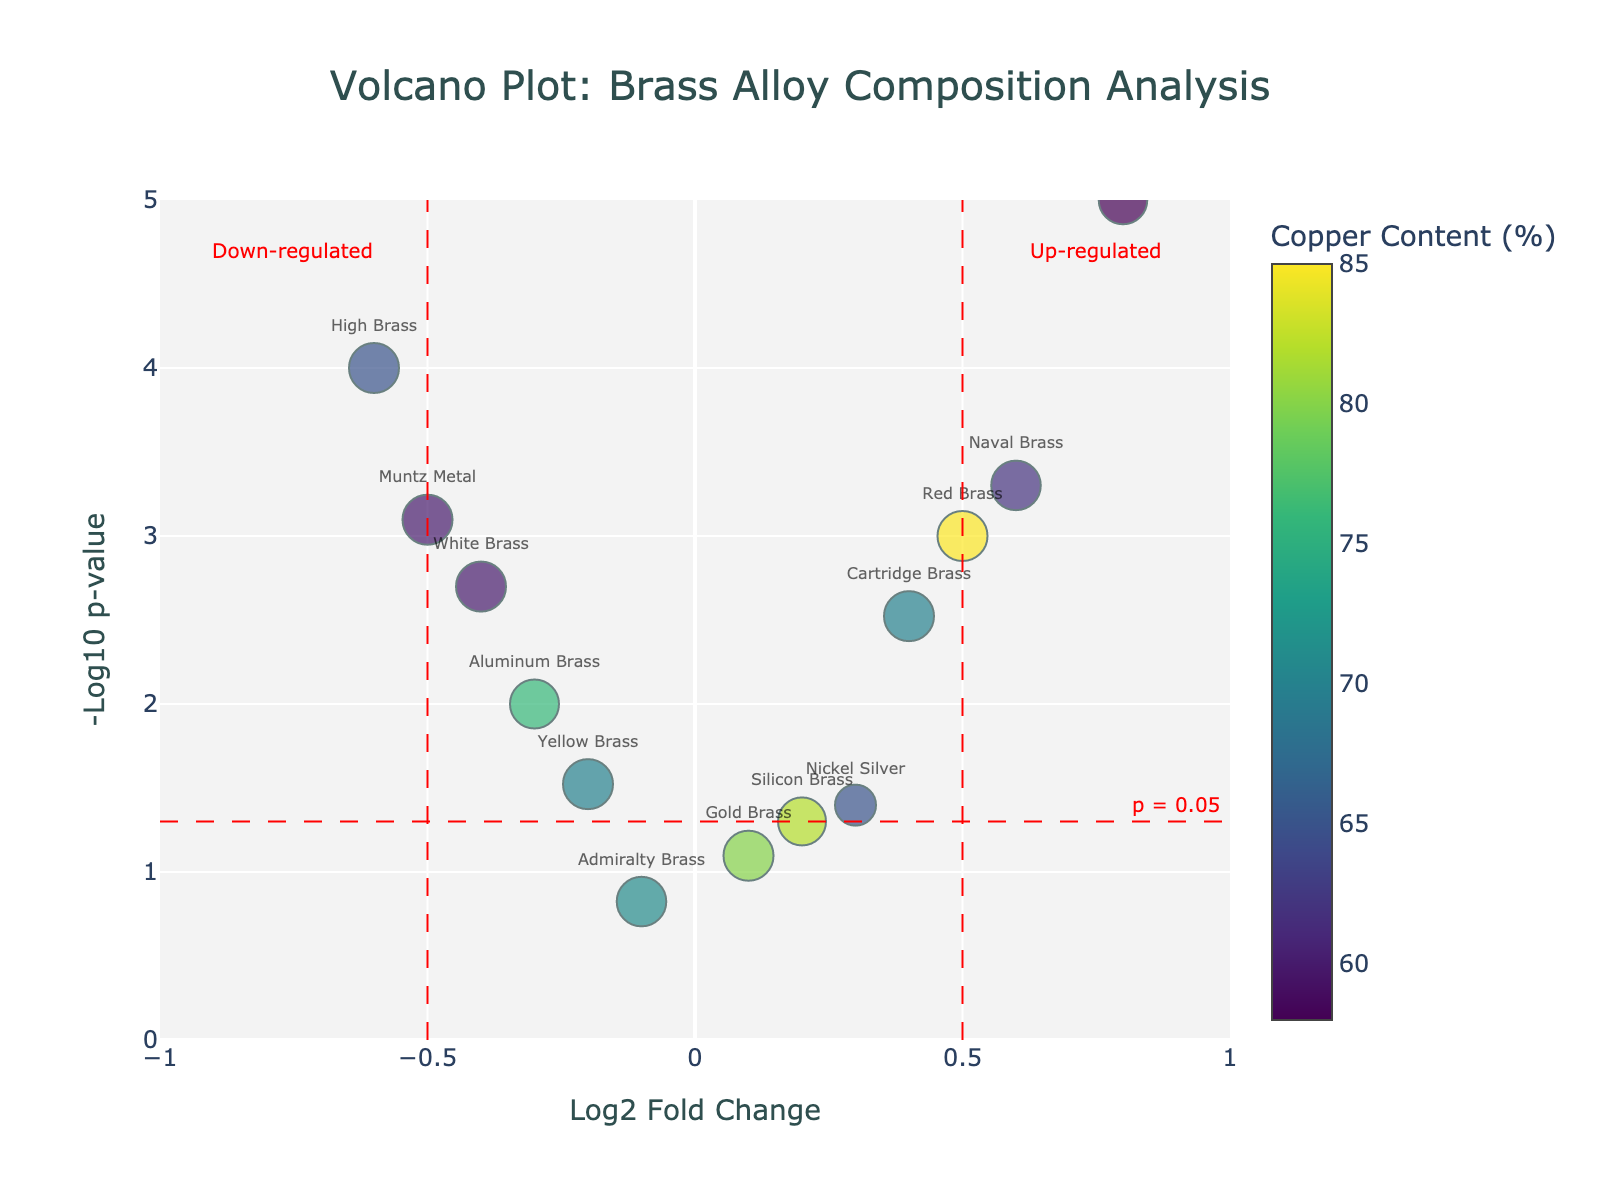What is the title of the figure? The title of the figure is found at the top of the plot. Reading it directly will give us the answer.
Answer: Volcano Plot: Brass Alloy Composition Analysis What do the x-axis and y-axis represent? The x-axis is labeled "Log2 Fold Change" which indicates the log base 2 of the fold change in alloy composition. The y-axis is labeled "-Log10 p-value" which shows the negative log base 10 of the p-value.
Answer: Log2 Fold Change and -Log10 p-value How many alloys have a log2 fold change greater than 0? By counting the markers on the plot to the right of the vertical line at x=0, we can determine how many alloys have a positive log2 fold change.
Answer: Seven Which alloy has the highest -log10 p-value? Identifying the point with the highest y-value and reading its label will tell us the alloy with the highest -log10 p-value.
Answer: Manganese Bronze Which alloy has the lowest log2 fold change? Finding the point farthest to the left on the x-axis and reading its label gives the alloy with the lowest log2 fold change.
Answer: High Brass What is the log2 fold change and -log10 p-value for Nickel Silver? Locate Nickel Silver on the plot and read its x and y coordinates to get the log2 fold change and -log10 p-value.
Answer: 0.3 and 1.40 Compare the copper content of Yellow Brass and Red Brass. Which one has a higher content? Check the color bar for copper content and compare the colors of Yellow Brass and Red Brass markers to see which is darker. Yellow Brass is darker, meaning it has more copper content as Copper Content increases with darker colors in the Viridis scale.
Answer: Yellow Brass Summarize the relationship between log2 fold change and p-value in the context of this plot. Observe that markers with low log2 fold change are clustered near the middle of the plot and that extremes in log2 fold change have higher -log10 p-values, implying a higher statistical significance.
Answer: Higher fold changes are generally more significant Identify an alloy that is significantly down-regulated and describe its characteristics. A significantly down-regulated alloy will be left of the vertical line at -0.5 and above the horizontal line at 1.3. The label accompanying this point is Muntz Metal. Summarize the description of this alloy.
Answer: Muntz Metal: log2 fold change of -0.5 and high significance What is the copper and zinc content of the alloy labeled "Cartridge Brass"? Locate Cartridge Brass on the plot, refer to the hover template or the mapped copper content color, and custom zinc content data to find these values.
Answer: 70% Copper and 30% Zinc 